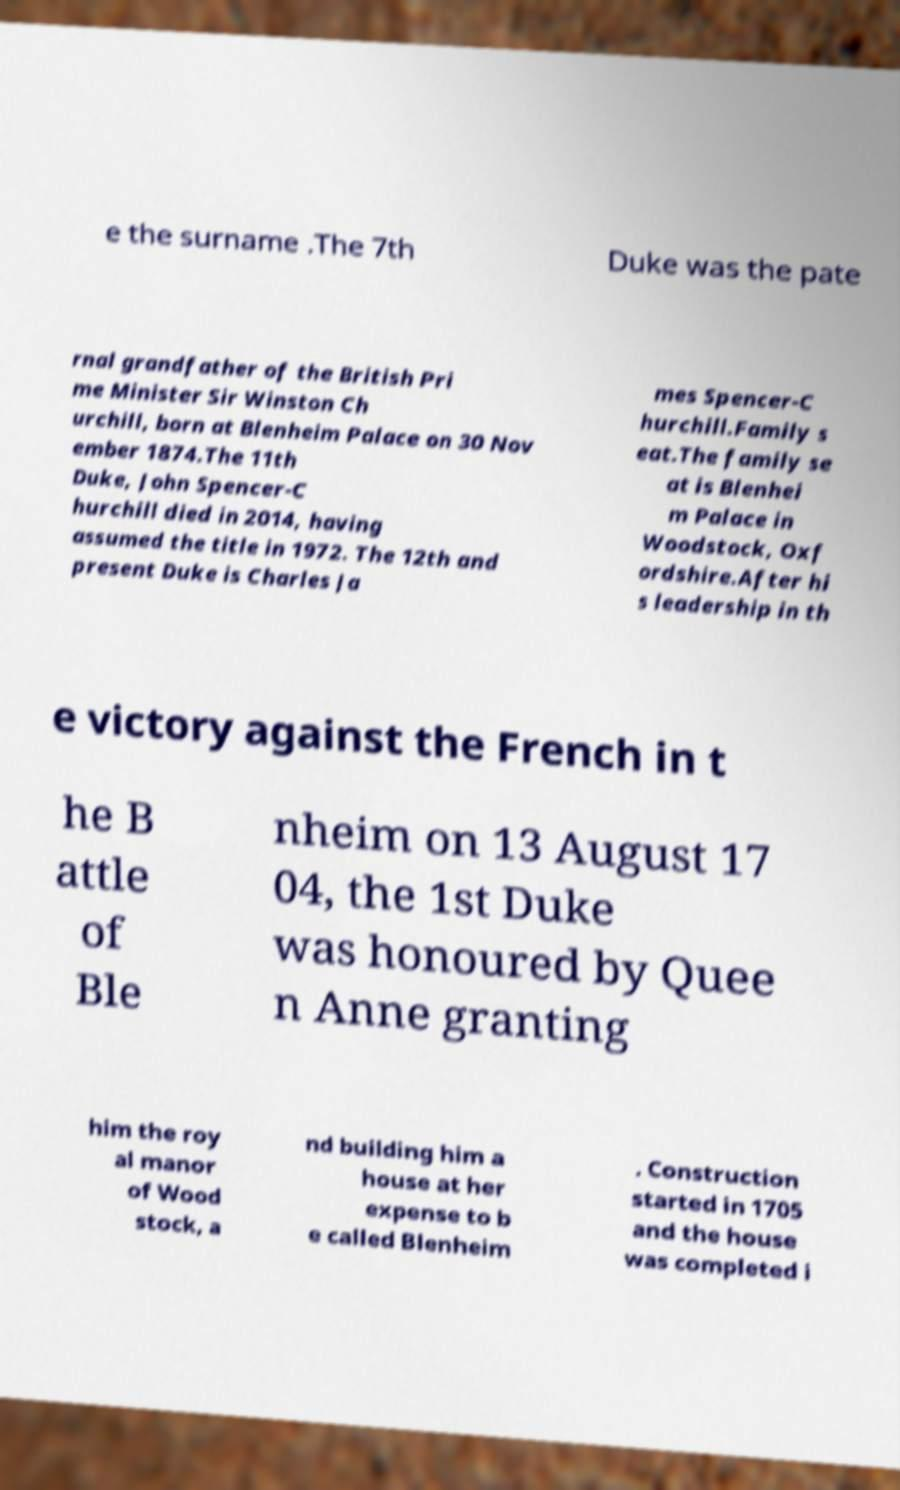Please read and relay the text visible in this image. What does it say? e the surname .The 7th Duke was the pate rnal grandfather of the British Pri me Minister Sir Winston Ch urchill, born at Blenheim Palace on 30 Nov ember 1874.The 11th Duke, John Spencer-C hurchill died in 2014, having assumed the title in 1972. The 12th and present Duke is Charles Ja mes Spencer-C hurchill.Family s eat.The family se at is Blenhei m Palace in Woodstock, Oxf ordshire.After hi s leadership in th e victory against the French in t he B attle of Ble nheim on 13 August 17 04, the 1st Duke was honoured by Quee n Anne granting him the roy al manor of Wood stock, a nd building him a house at her expense to b e called Blenheim . Construction started in 1705 and the house was completed i 